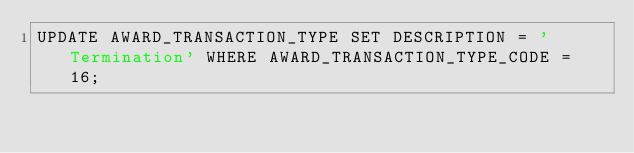<code> <loc_0><loc_0><loc_500><loc_500><_SQL_>UPDATE AWARD_TRANSACTION_TYPE SET DESCRIPTION = 'Termination' WHERE AWARD_TRANSACTION_TYPE_CODE = 16;
</code> 